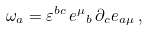<formula> <loc_0><loc_0><loc_500><loc_500>\omega _ { a } = \varepsilon ^ { b c } \, { e ^ { \mu } } _ { b } \, \partial _ { c } e _ { a \mu } \, ,</formula> 